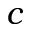<formula> <loc_0><loc_0><loc_500><loc_500>c</formula> 